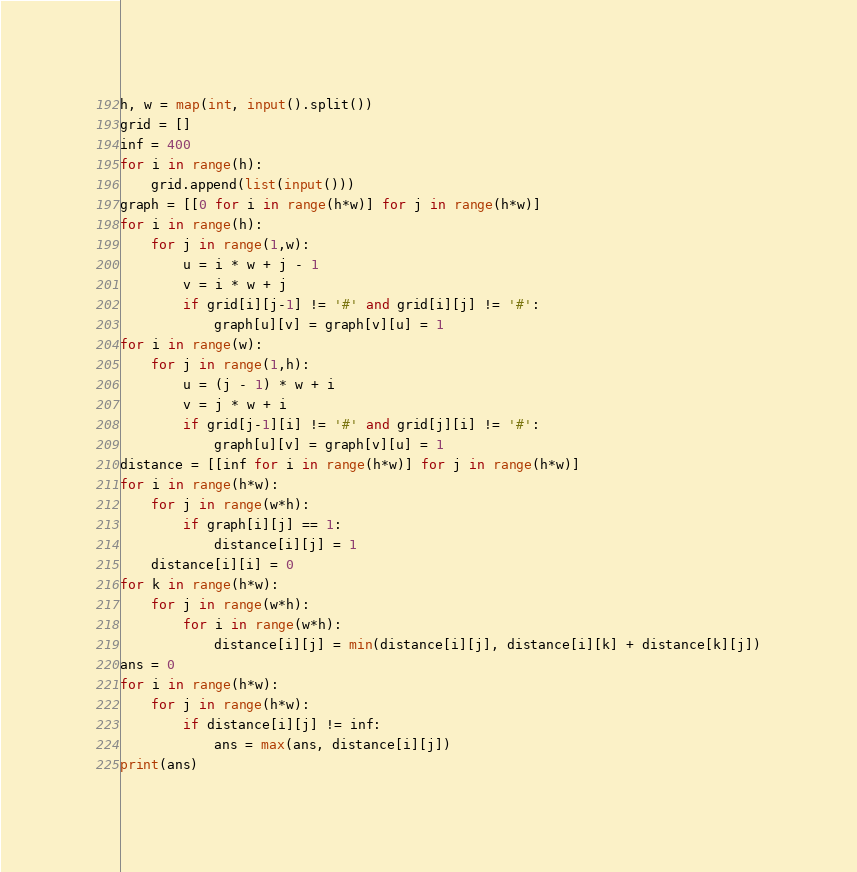<code> <loc_0><loc_0><loc_500><loc_500><_Python_>h, w = map(int, input().split())
grid = []
inf = 400
for i in range(h):
    grid.append(list(input()))
graph = [[0 for i in range(h*w)] for j in range(h*w)]
for i in range(h):
    for j in range(1,w):
        u = i * w + j - 1
        v = i * w + j
        if grid[i][j-1] != '#' and grid[i][j] != '#':
            graph[u][v] = graph[v][u] = 1
for i in range(w):
    for j in range(1,h):
        u = (j - 1) * w + i
        v = j * w + i
        if grid[j-1][i] != '#' and grid[j][i] != '#':
            graph[u][v] = graph[v][u] = 1
distance = [[inf for i in range(h*w)] for j in range(h*w)]
for i in range(h*w):
    for j in range(w*h):
        if graph[i][j] == 1:
            distance[i][j] = 1
    distance[i][i] = 0
for k in range(h*w):
    for j in range(w*h):
        for i in range(w*h):
            distance[i][j] = min(distance[i][j], distance[i][k] + distance[k][j])
ans = 0
for i in range(h*w):
    for j in range(h*w):
        if distance[i][j] != inf:
            ans = max(ans, distance[i][j])
print(ans)</code> 